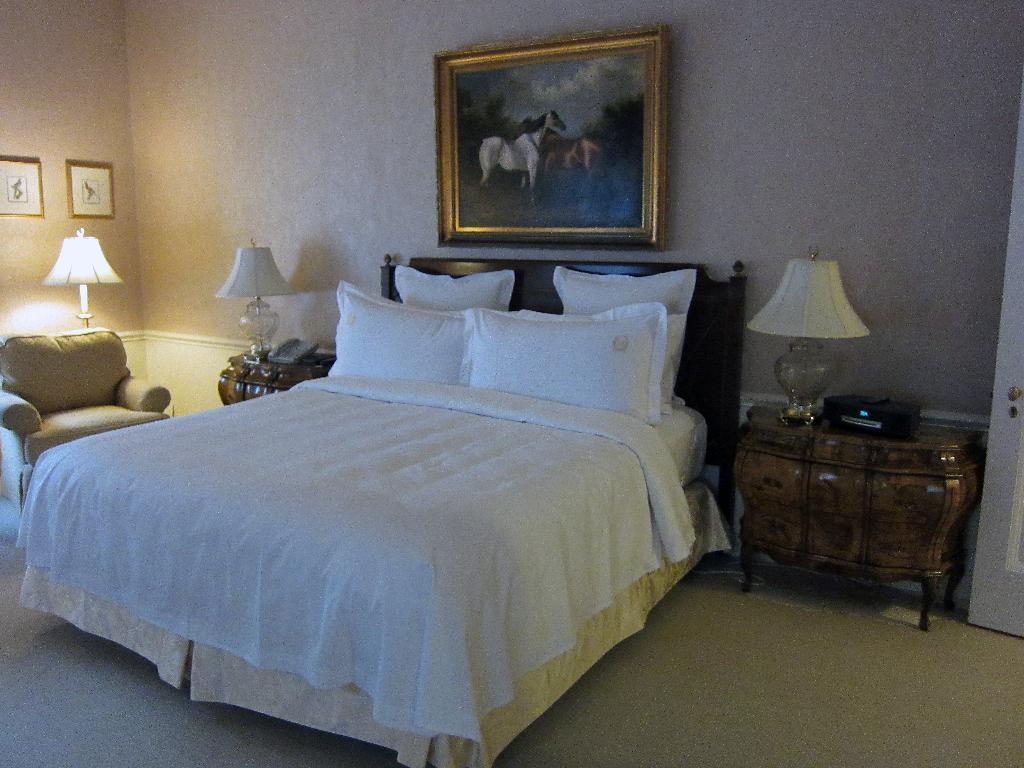Can you describe this image briefly? A room which has a bed on that a bed sheet of white color and four pillows. We have three lamps in the room and a sofa and on the other side of wall we have two photo frames and on the bed side wall we have a photo frame of horse. And also a telephone on the table and beside the bed we have a table which has a lamp on it. 